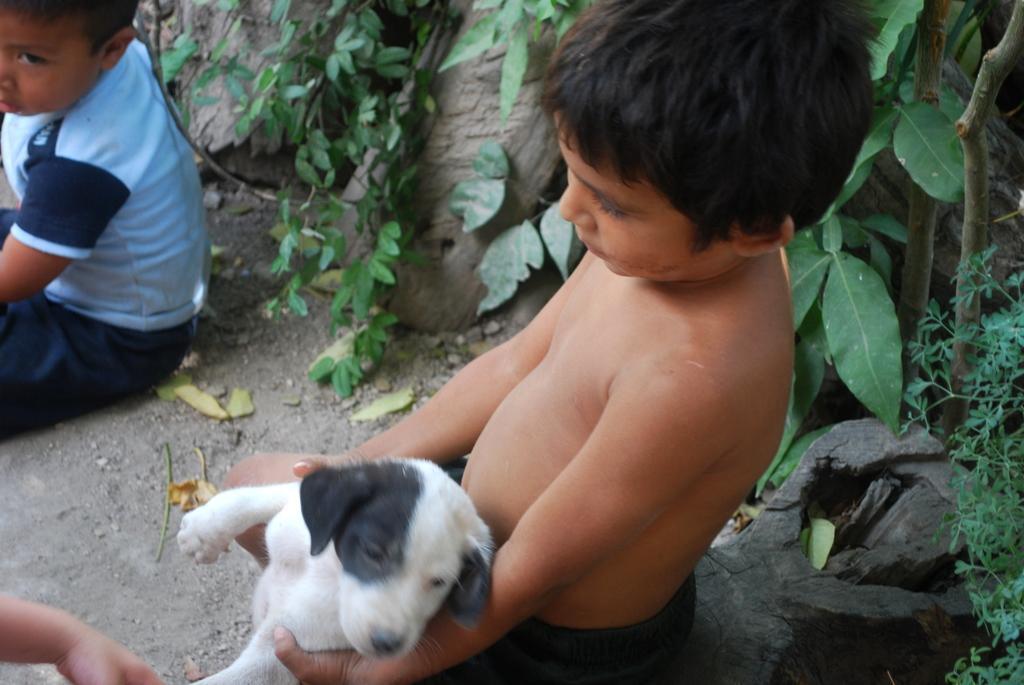Please provide a concise description of this image. In this picture we can see a boy who is holding a dog with his hands. And this is plant. 